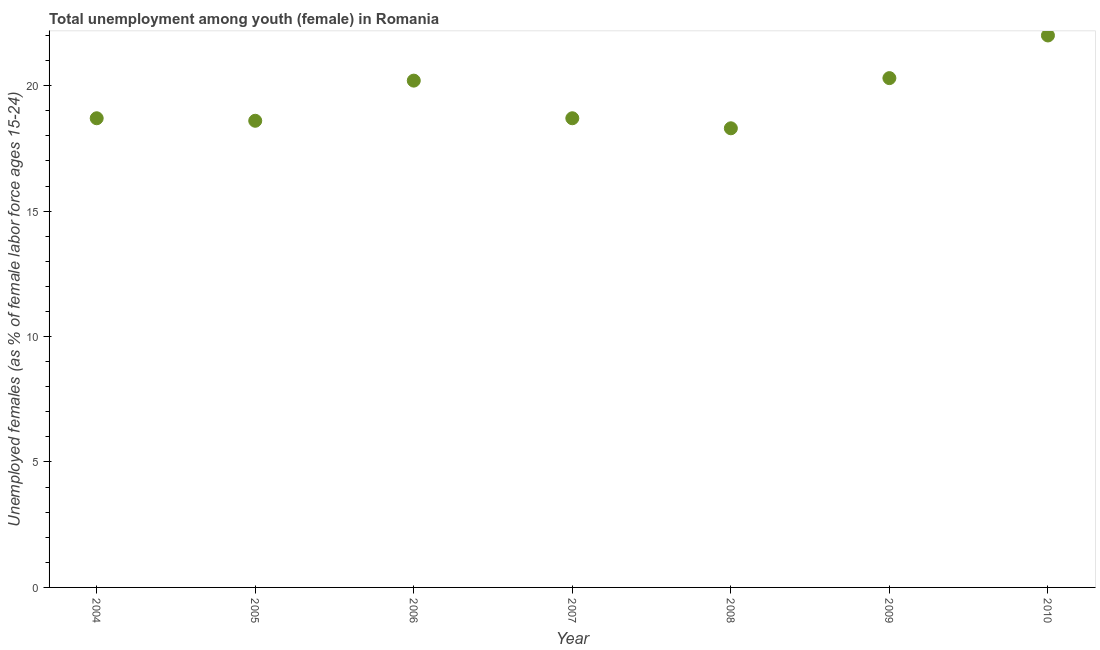What is the unemployed female youth population in 2006?
Your answer should be compact. 20.2. Across all years, what is the maximum unemployed female youth population?
Provide a short and direct response. 22. Across all years, what is the minimum unemployed female youth population?
Provide a succinct answer. 18.3. What is the sum of the unemployed female youth population?
Provide a short and direct response. 136.8. What is the difference between the unemployed female youth population in 2007 and 2009?
Provide a short and direct response. -1.6. What is the average unemployed female youth population per year?
Provide a succinct answer. 19.54. What is the median unemployed female youth population?
Offer a very short reply. 18.7. In how many years, is the unemployed female youth population greater than 11 %?
Offer a very short reply. 7. Do a majority of the years between 2005 and 2006 (inclusive) have unemployed female youth population greater than 10 %?
Give a very brief answer. Yes. What is the ratio of the unemployed female youth population in 2005 to that in 2010?
Keep it short and to the point. 0.85. Is the difference between the unemployed female youth population in 2004 and 2010 greater than the difference between any two years?
Make the answer very short. No. What is the difference between the highest and the second highest unemployed female youth population?
Make the answer very short. 1.7. What is the difference between the highest and the lowest unemployed female youth population?
Offer a very short reply. 3.7. In how many years, is the unemployed female youth population greater than the average unemployed female youth population taken over all years?
Provide a succinct answer. 3. What is the title of the graph?
Keep it short and to the point. Total unemployment among youth (female) in Romania. What is the label or title of the Y-axis?
Your answer should be very brief. Unemployed females (as % of female labor force ages 15-24). What is the Unemployed females (as % of female labor force ages 15-24) in 2004?
Provide a succinct answer. 18.7. What is the Unemployed females (as % of female labor force ages 15-24) in 2005?
Ensure brevity in your answer.  18.6. What is the Unemployed females (as % of female labor force ages 15-24) in 2006?
Offer a very short reply. 20.2. What is the Unemployed females (as % of female labor force ages 15-24) in 2007?
Offer a terse response. 18.7. What is the Unemployed females (as % of female labor force ages 15-24) in 2008?
Provide a succinct answer. 18.3. What is the Unemployed females (as % of female labor force ages 15-24) in 2009?
Ensure brevity in your answer.  20.3. What is the difference between the Unemployed females (as % of female labor force ages 15-24) in 2004 and 2005?
Offer a very short reply. 0.1. What is the difference between the Unemployed females (as % of female labor force ages 15-24) in 2004 and 2007?
Your response must be concise. 0. What is the difference between the Unemployed females (as % of female labor force ages 15-24) in 2004 and 2008?
Give a very brief answer. 0.4. What is the difference between the Unemployed females (as % of female labor force ages 15-24) in 2004 and 2009?
Your response must be concise. -1.6. What is the difference between the Unemployed females (as % of female labor force ages 15-24) in 2004 and 2010?
Provide a succinct answer. -3.3. What is the difference between the Unemployed females (as % of female labor force ages 15-24) in 2005 and 2007?
Your answer should be compact. -0.1. What is the difference between the Unemployed females (as % of female labor force ages 15-24) in 2005 and 2008?
Your answer should be very brief. 0.3. What is the difference between the Unemployed females (as % of female labor force ages 15-24) in 2005 and 2010?
Your answer should be very brief. -3.4. What is the difference between the Unemployed females (as % of female labor force ages 15-24) in 2006 and 2007?
Provide a short and direct response. 1.5. What is the difference between the Unemployed females (as % of female labor force ages 15-24) in 2006 and 2008?
Offer a terse response. 1.9. What is the difference between the Unemployed females (as % of female labor force ages 15-24) in 2006 and 2009?
Your answer should be very brief. -0.1. What is the difference between the Unemployed females (as % of female labor force ages 15-24) in 2007 and 2008?
Keep it short and to the point. 0.4. What is the difference between the Unemployed females (as % of female labor force ages 15-24) in 2007 and 2010?
Offer a very short reply. -3.3. What is the difference between the Unemployed females (as % of female labor force ages 15-24) in 2008 and 2009?
Your response must be concise. -2. What is the difference between the Unemployed females (as % of female labor force ages 15-24) in 2008 and 2010?
Your response must be concise. -3.7. What is the difference between the Unemployed females (as % of female labor force ages 15-24) in 2009 and 2010?
Provide a short and direct response. -1.7. What is the ratio of the Unemployed females (as % of female labor force ages 15-24) in 2004 to that in 2006?
Provide a succinct answer. 0.93. What is the ratio of the Unemployed females (as % of female labor force ages 15-24) in 2004 to that in 2008?
Make the answer very short. 1.02. What is the ratio of the Unemployed females (as % of female labor force ages 15-24) in 2004 to that in 2009?
Make the answer very short. 0.92. What is the ratio of the Unemployed females (as % of female labor force ages 15-24) in 2005 to that in 2006?
Offer a very short reply. 0.92. What is the ratio of the Unemployed females (as % of female labor force ages 15-24) in 2005 to that in 2007?
Your response must be concise. 0.99. What is the ratio of the Unemployed females (as % of female labor force ages 15-24) in 2005 to that in 2008?
Your response must be concise. 1.02. What is the ratio of the Unemployed females (as % of female labor force ages 15-24) in 2005 to that in 2009?
Your answer should be compact. 0.92. What is the ratio of the Unemployed females (as % of female labor force ages 15-24) in 2005 to that in 2010?
Your answer should be very brief. 0.84. What is the ratio of the Unemployed females (as % of female labor force ages 15-24) in 2006 to that in 2007?
Your response must be concise. 1.08. What is the ratio of the Unemployed females (as % of female labor force ages 15-24) in 2006 to that in 2008?
Keep it short and to the point. 1.1. What is the ratio of the Unemployed females (as % of female labor force ages 15-24) in 2006 to that in 2009?
Offer a very short reply. 0.99. What is the ratio of the Unemployed females (as % of female labor force ages 15-24) in 2006 to that in 2010?
Offer a terse response. 0.92. What is the ratio of the Unemployed females (as % of female labor force ages 15-24) in 2007 to that in 2008?
Offer a terse response. 1.02. What is the ratio of the Unemployed females (as % of female labor force ages 15-24) in 2007 to that in 2009?
Your response must be concise. 0.92. What is the ratio of the Unemployed females (as % of female labor force ages 15-24) in 2008 to that in 2009?
Your answer should be compact. 0.9. What is the ratio of the Unemployed females (as % of female labor force ages 15-24) in 2008 to that in 2010?
Provide a succinct answer. 0.83. What is the ratio of the Unemployed females (as % of female labor force ages 15-24) in 2009 to that in 2010?
Your response must be concise. 0.92. 